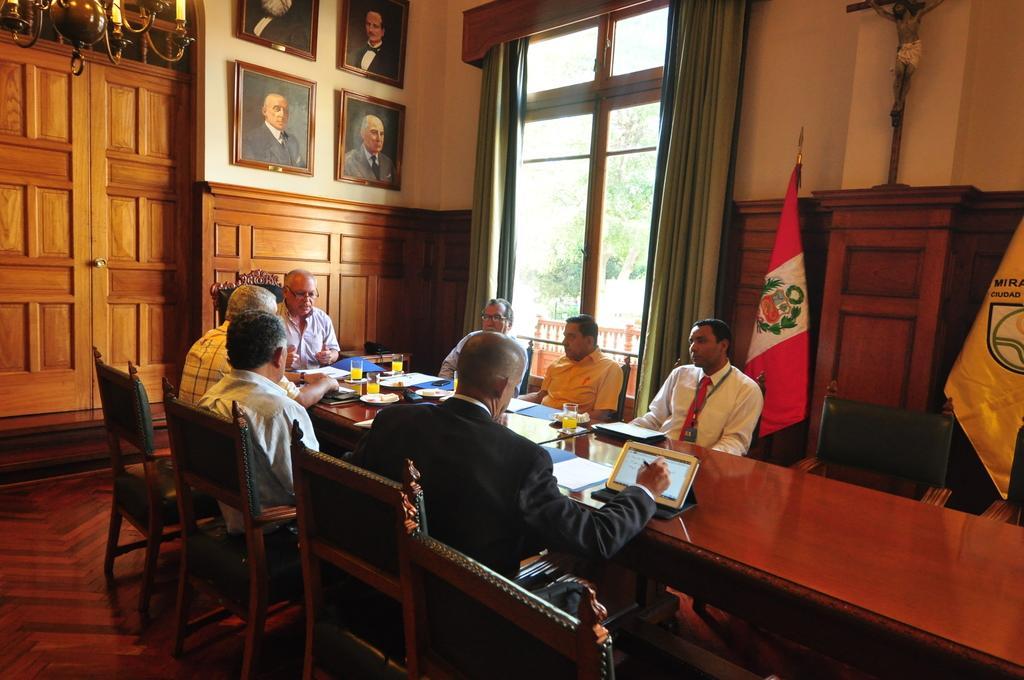Please provide a concise description of this image. In this picture here we can see 7 persons sitting on the chairs around a table, this seems like some conference meeting and here the person at the center wearing black blazer is looking at the tablet and doing something. In the background we can see wall, photo frames, curtain, glass window flags, jesus christ statue. It seems like conference hall. 